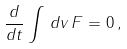<formula> <loc_0><loc_0><loc_500><loc_500>\frac { d } { d t } \int \, d v \, F = 0 \, ,</formula> 